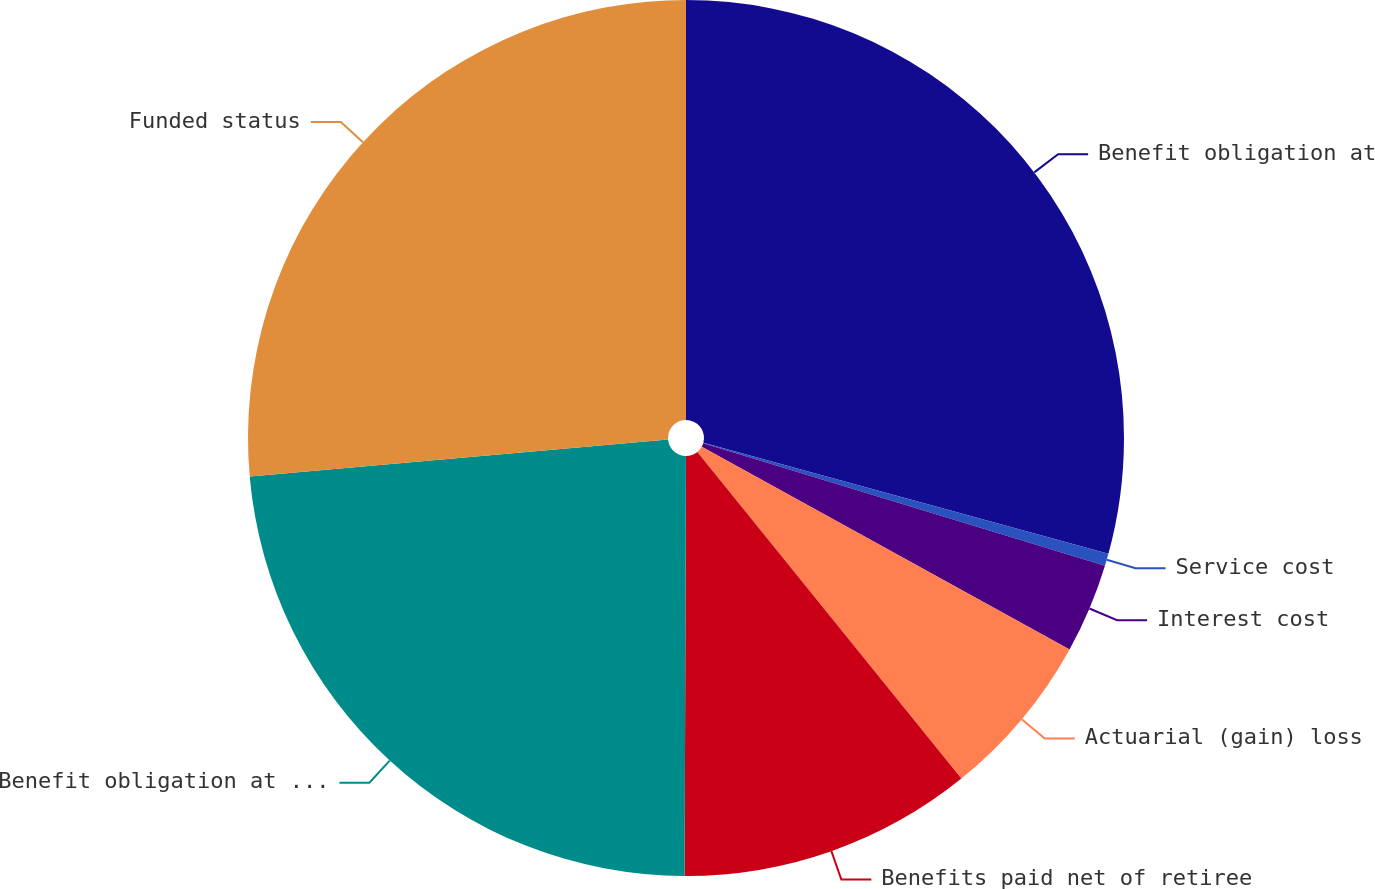Convert chart. <chart><loc_0><loc_0><loc_500><loc_500><pie_chart><fcel>Benefit obligation at<fcel>Service cost<fcel>Interest cost<fcel>Actuarial (gain) loss<fcel>Benefits paid net of retiree<fcel>Benefit obligation at end of<fcel>Funded status<nl><fcel>29.26%<fcel>0.45%<fcel>3.31%<fcel>6.16%<fcel>10.87%<fcel>23.55%<fcel>26.4%<nl></chart> 